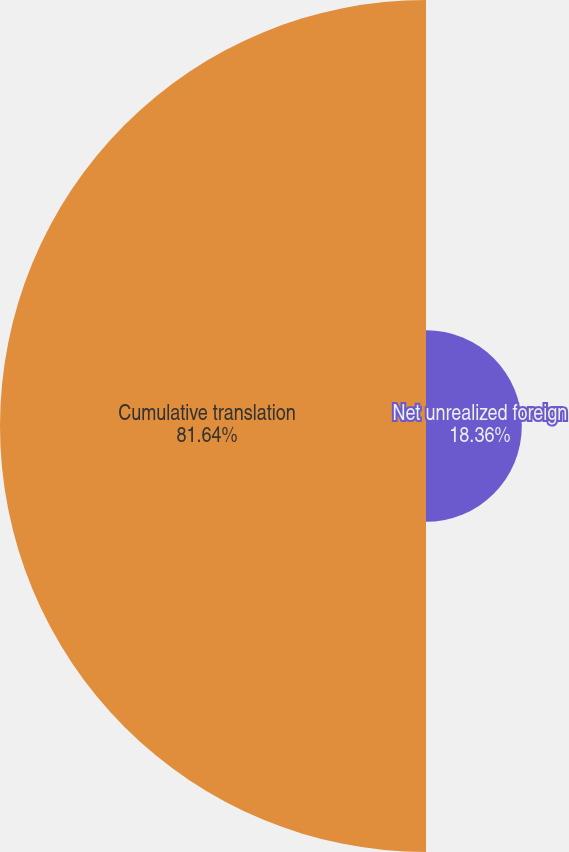Convert chart. <chart><loc_0><loc_0><loc_500><loc_500><pie_chart><fcel>Net unrealized foreign<fcel>Cumulative translation<nl><fcel>18.36%<fcel>81.64%<nl></chart> 